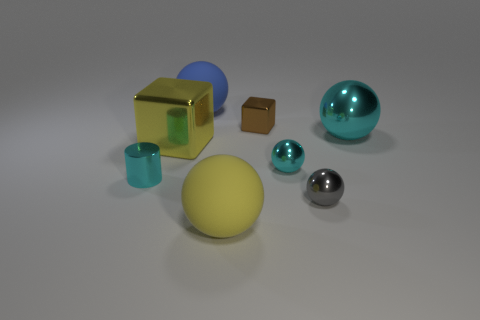Subtract 1 balls. How many balls are left? 4 Subtract all gray balls. How many balls are left? 4 Subtract all tiny gray balls. How many balls are left? 4 Add 1 tiny blue things. How many objects exist? 9 Subtract all yellow balls. Subtract all blue cylinders. How many balls are left? 4 Subtract all blocks. How many objects are left? 6 Add 3 large matte things. How many large matte things exist? 5 Subtract 0 green cubes. How many objects are left? 8 Subtract all big purple cylinders. Subtract all big yellow shiny cubes. How many objects are left? 7 Add 7 blue matte objects. How many blue matte objects are left? 8 